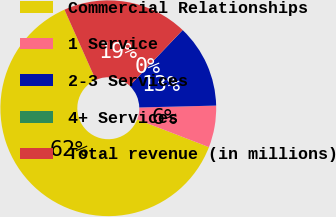Convert chart to OTSL. <chart><loc_0><loc_0><loc_500><loc_500><pie_chart><fcel>Commercial Relationships<fcel>1 Service<fcel>2-3 Services<fcel>4+ Services<fcel>Total revenue (in millions)<nl><fcel>62.47%<fcel>6.26%<fcel>12.5%<fcel>0.01%<fcel>18.75%<nl></chart> 